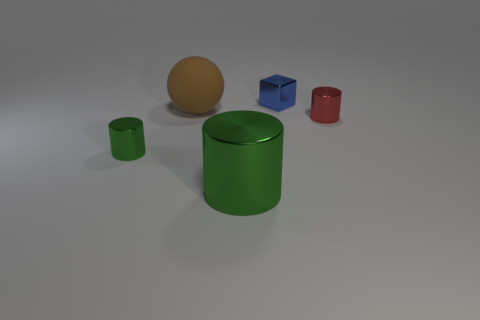Are any red metal cylinders visible? Yes, one can observe a small red cylinder with a metallic sheen, which indicates its material composition. 